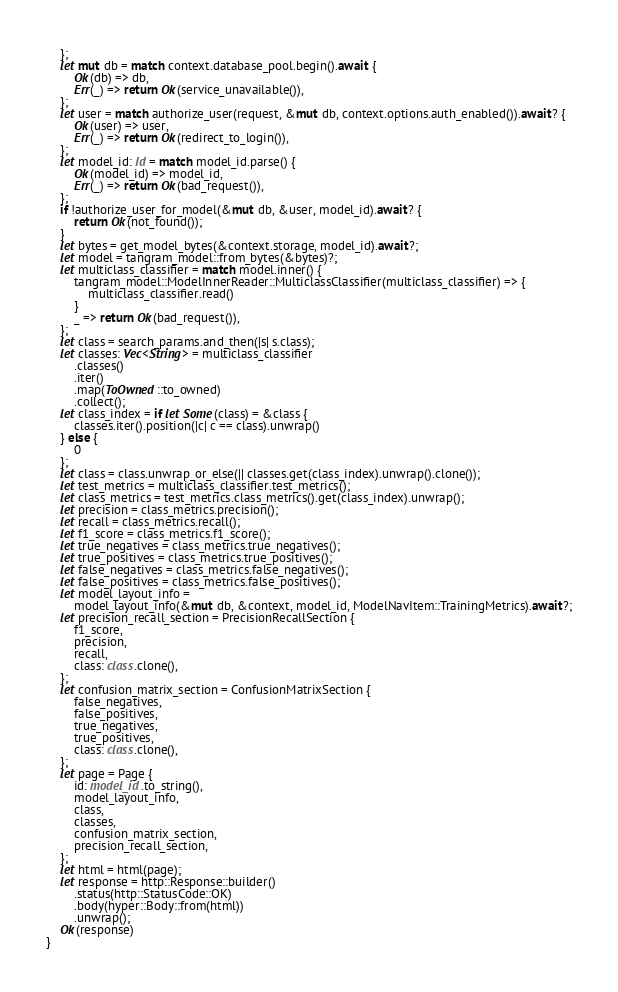<code> <loc_0><loc_0><loc_500><loc_500><_Rust_>	};
	let mut db = match context.database_pool.begin().await {
		Ok(db) => db,
		Err(_) => return Ok(service_unavailable()),
	};
	let user = match authorize_user(request, &mut db, context.options.auth_enabled()).await? {
		Ok(user) => user,
		Err(_) => return Ok(redirect_to_login()),
	};
	let model_id: Id = match model_id.parse() {
		Ok(model_id) => model_id,
		Err(_) => return Ok(bad_request()),
	};
	if !authorize_user_for_model(&mut db, &user, model_id).await? {
		return Ok(not_found());
	}
	let bytes = get_model_bytes(&context.storage, model_id).await?;
	let model = tangram_model::from_bytes(&bytes)?;
	let multiclass_classifier = match model.inner() {
		tangram_model::ModelInnerReader::MulticlassClassifier(multiclass_classifier) => {
			multiclass_classifier.read()
		}
		_ => return Ok(bad_request()),
	};
	let class = search_params.and_then(|s| s.class);
	let classes: Vec<String> = multiclass_classifier
		.classes()
		.iter()
		.map(ToOwned::to_owned)
		.collect();
	let class_index = if let Some(class) = &class {
		classes.iter().position(|c| c == class).unwrap()
	} else {
		0
	};
	let class = class.unwrap_or_else(|| classes.get(class_index).unwrap().clone());
	let test_metrics = multiclass_classifier.test_metrics();
	let class_metrics = test_metrics.class_metrics().get(class_index).unwrap();
	let precision = class_metrics.precision();
	let recall = class_metrics.recall();
	let f1_score = class_metrics.f1_score();
	let true_negatives = class_metrics.true_negatives();
	let true_positives = class_metrics.true_positives();
	let false_negatives = class_metrics.false_negatives();
	let false_positives = class_metrics.false_positives();
	let model_layout_info =
		model_layout_info(&mut db, &context, model_id, ModelNavItem::TrainingMetrics).await?;
	let precision_recall_section = PrecisionRecallSection {
		f1_score,
		precision,
		recall,
		class: class.clone(),
	};
	let confusion_matrix_section = ConfusionMatrixSection {
		false_negatives,
		false_positives,
		true_negatives,
		true_positives,
		class: class.clone(),
	};
	let page = Page {
		id: model_id.to_string(),
		model_layout_info,
		class,
		classes,
		confusion_matrix_section,
		precision_recall_section,
	};
	let html = html(page);
	let response = http::Response::builder()
		.status(http::StatusCode::OK)
		.body(hyper::Body::from(html))
		.unwrap();
	Ok(response)
}
</code> 